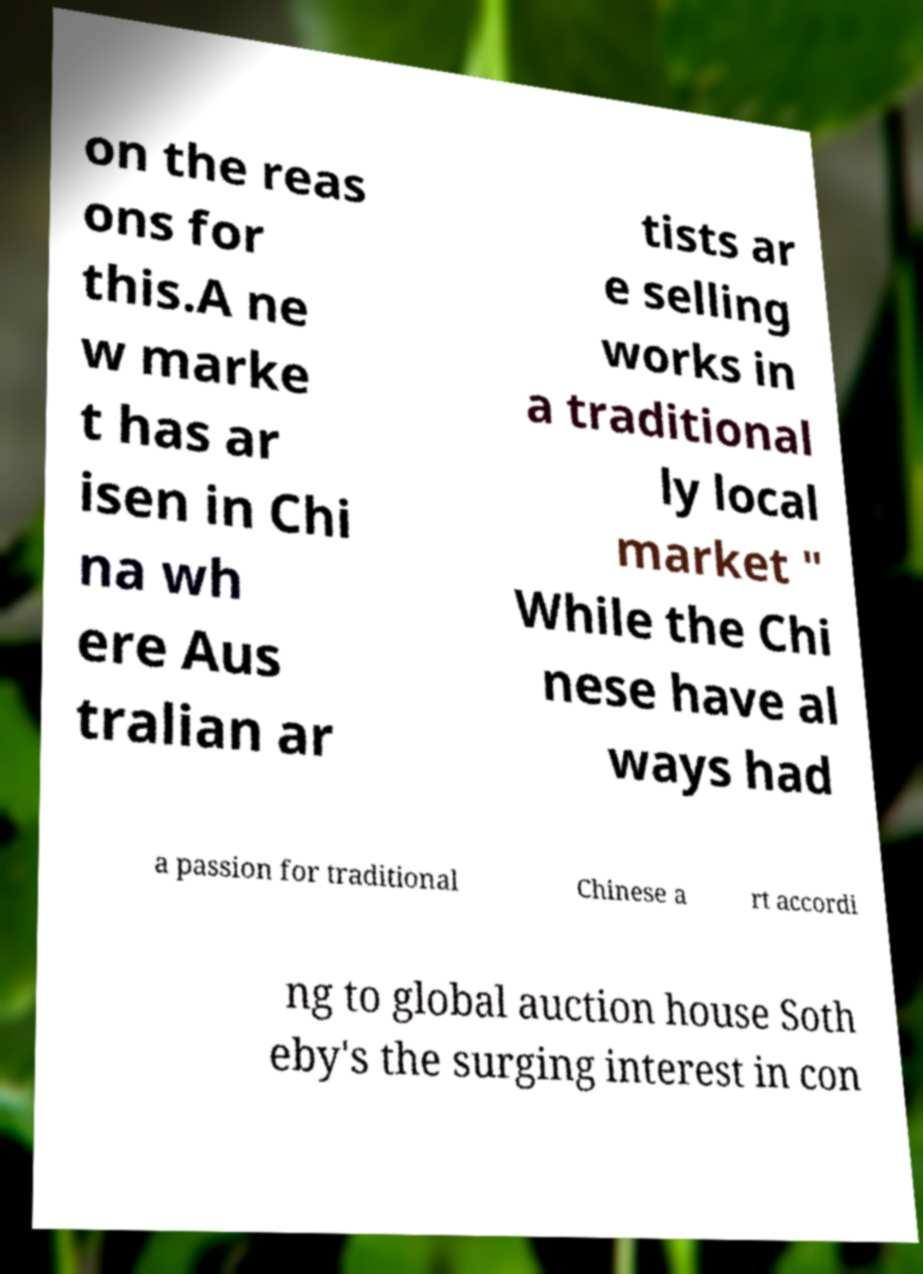What messages or text are displayed in this image? I need them in a readable, typed format. on the reas ons for this.A ne w marke t has ar isen in Chi na wh ere Aus tralian ar tists ar e selling works in a traditional ly local market " While the Chi nese have al ways had a passion for traditional Chinese a rt accordi ng to global auction house Soth eby's the surging interest in con 